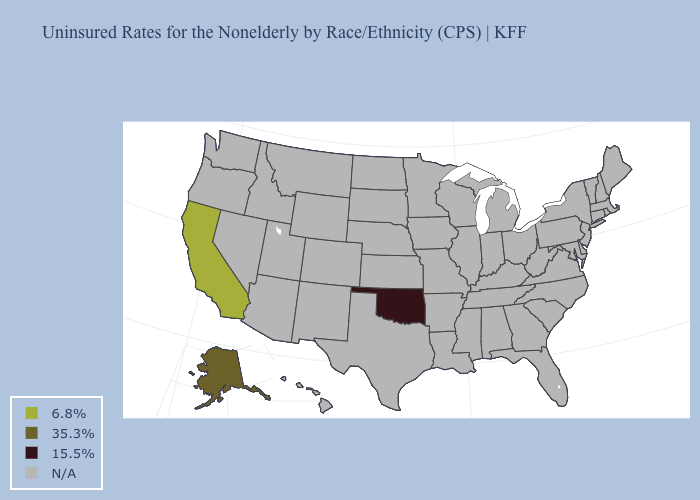Name the states that have a value in the range 35.3%?
Keep it brief. Alaska. Does California have the highest value in the USA?
Keep it brief. Yes. Does Alaska have the lowest value in the West?
Short answer required. Yes. How many symbols are there in the legend?
Answer briefly. 4. Does the first symbol in the legend represent the smallest category?
Concise answer only. No. Name the states that have a value in the range 6.8%?
Short answer required. California. Which states have the lowest value in the USA?
Concise answer only. Oklahoma. Name the states that have a value in the range 15.5%?
Write a very short answer. Oklahoma. Does Alaska have the highest value in the USA?
Answer briefly. No. What is the lowest value in the USA?
Keep it brief. 15.5%. What is the value of Georgia?
Short answer required. N/A. How many symbols are there in the legend?
Be succinct. 4. 